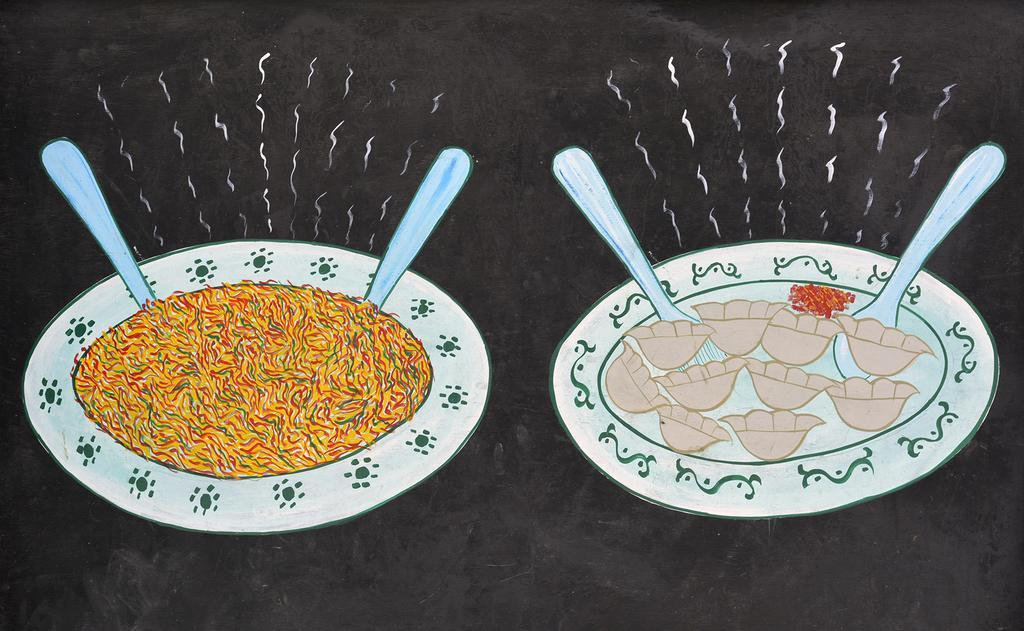Please provide a concise description of this image. There is a drawing of 2 white plates which have food items and 2 spoons in it. There is a black background. 